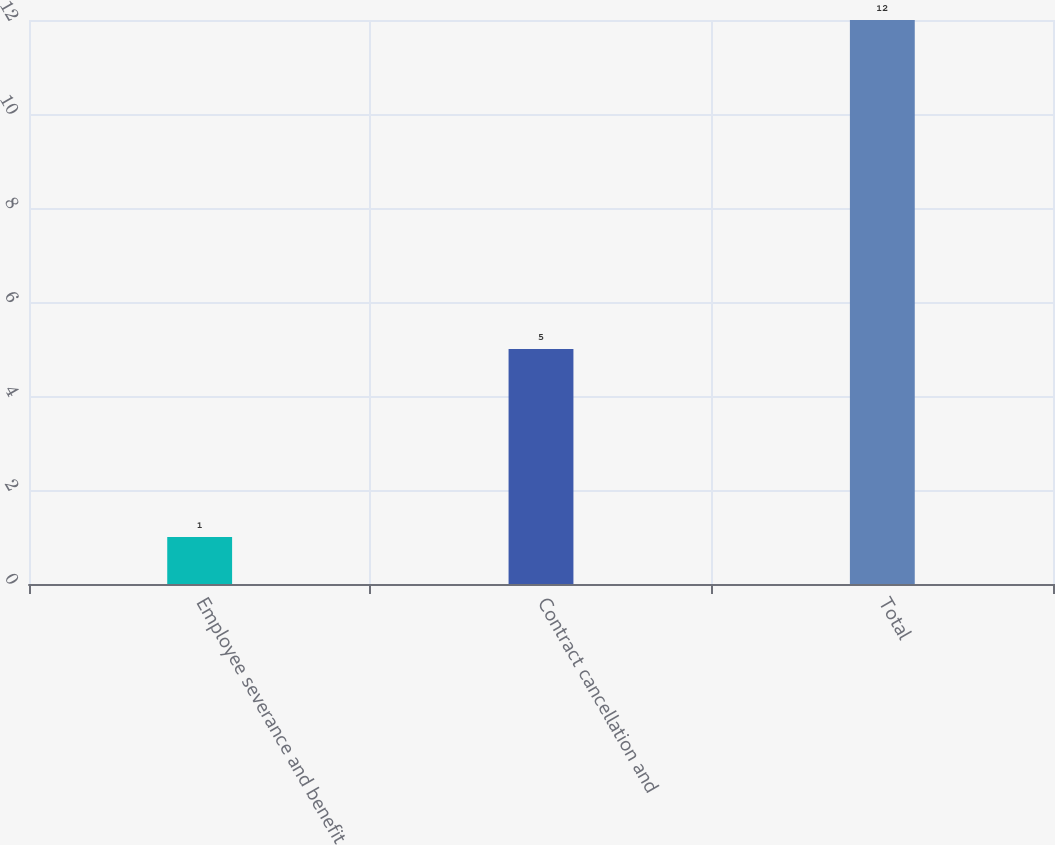<chart> <loc_0><loc_0><loc_500><loc_500><bar_chart><fcel>Employee severance and benefit<fcel>Contract cancellation and<fcel>Total<nl><fcel>1<fcel>5<fcel>12<nl></chart> 